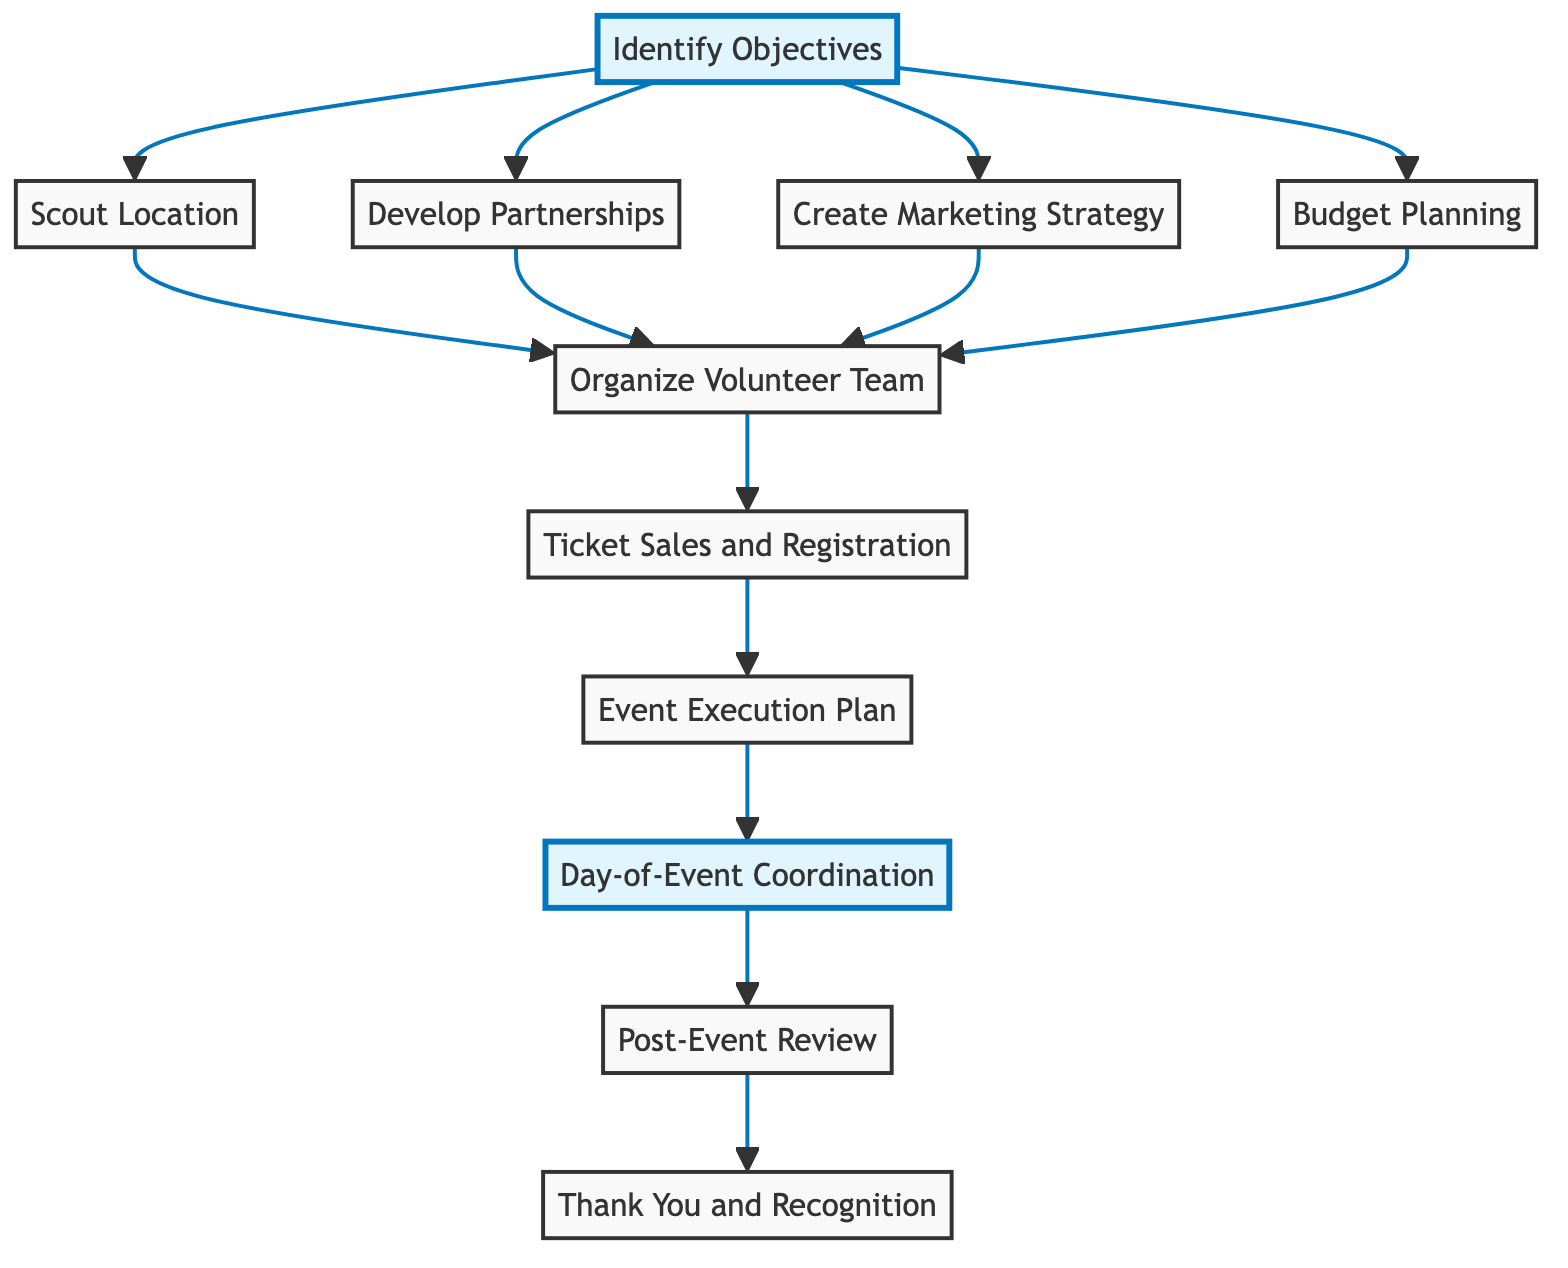What is the starting point of the flow chart? The starting point is "Identify Objectives," which is the first step in the flowchart.
Answer: Identify Objectives How many main steps are there in the flow chart? There are a total of 11 main steps represented in the flowchart, from "Identify Objectives" to "Thank You and Recognition."
Answer: 11 Which step comes after "Organize Volunteer Team"? The step that comes after "Organize Volunteer Team" is "Ticket Sales and Registration."
Answer: Ticket Sales and Registration List the three steps that directly follow "Scout Location." The three steps that follow "Scout Location" are "Develop Partnerships," "Create Marketing Strategy," and "Budget Planning," which are linked directly from "Scout Location."
Answer: Develop Partnerships, Create Marketing Strategy, Budget Planning What is the final step in the flow chart? The final step in the flow chart is "Thank You and Recognition," which comes after the "Post-Event Review."
Answer: Thank You and Recognition Which elements must be completed before proceeding to "Organize Volunteer Team"? The elements that must be completed are "Scout Location," "Develop Partnerships," "Create Marketing Strategy," and "Budget Planning" before reaching "Organize Volunteer Team."
Answer: Scout Location, Develop Partnerships, Create Marketing Strategy, Budget Planning Is "Day-of-Event Coordination" a highlighted step in the flow chart? Yes, "Day-of-Event Coordination" is highlighted, indicating its significance in the event coordination process.
Answer: Yes What is the relationship between "Event Execution Plan" and "Day-of-Event Coordination"? "Day-of-Event Coordination" follows directly from "Event Execution Plan," meaning that it depends on the execution plan to proceed.
Answer: Day-of-Event Coordination follows Event Execution Plan Which steps require feedback collection? "Post-Event Review" requires feedback collection to analyze outcomes against objectives, as indicated in the flow.
Answer: Post-Event Review 